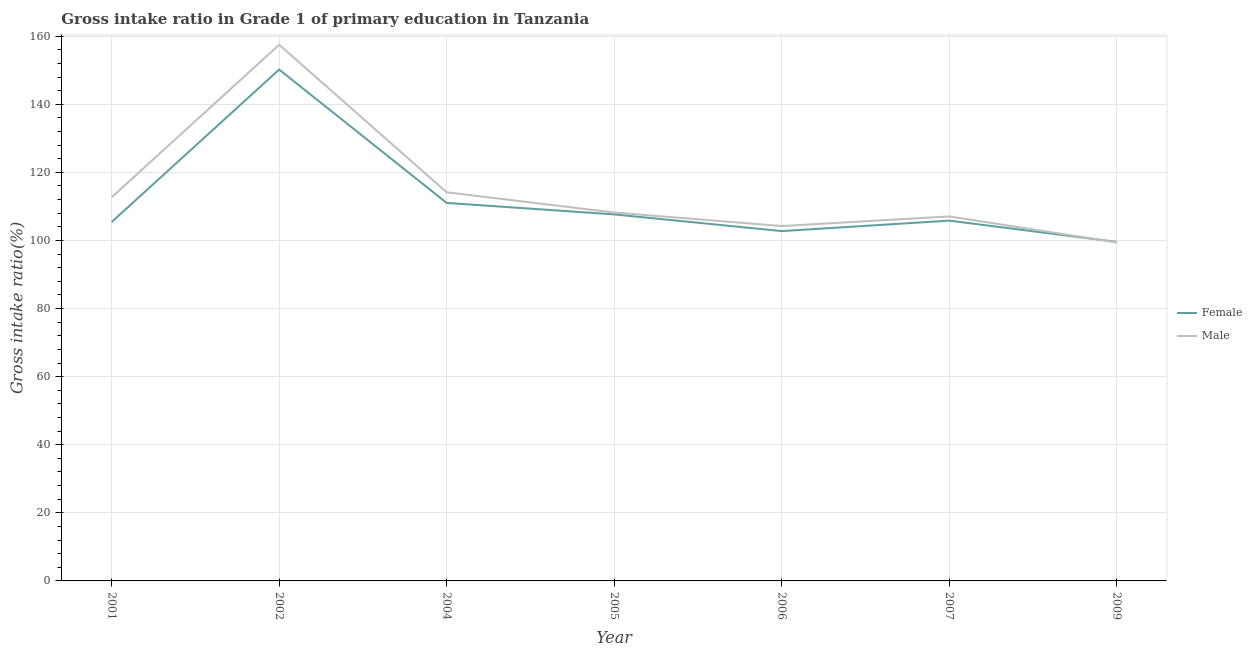Is the number of lines equal to the number of legend labels?
Your answer should be very brief. Yes. What is the gross intake ratio(male) in 2005?
Provide a succinct answer. 108.2. Across all years, what is the maximum gross intake ratio(male)?
Your response must be concise. 157.48. Across all years, what is the minimum gross intake ratio(male)?
Keep it short and to the point. 99.43. What is the total gross intake ratio(male) in the graph?
Give a very brief answer. 803.22. What is the difference between the gross intake ratio(male) in 2005 and that in 2009?
Your answer should be very brief. 8.77. What is the difference between the gross intake ratio(male) in 2001 and the gross intake ratio(female) in 2002?
Your answer should be compact. -37.51. What is the average gross intake ratio(male) per year?
Provide a succinct answer. 114.75. In the year 2002, what is the difference between the gross intake ratio(male) and gross intake ratio(female)?
Give a very brief answer. 7.28. In how many years, is the gross intake ratio(female) greater than 84 %?
Offer a terse response. 7. What is the ratio of the gross intake ratio(female) in 2001 to that in 2007?
Make the answer very short. 1. Is the gross intake ratio(female) in 2002 less than that in 2005?
Provide a succinct answer. No. Is the difference between the gross intake ratio(female) in 2002 and 2005 greater than the difference between the gross intake ratio(male) in 2002 and 2005?
Make the answer very short. No. What is the difference between the highest and the second highest gross intake ratio(female)?
Make the answer very short. 39.18. What is the difference between the highest and the lowest gross intake ratio(female)?
Provide a short and direct response. 50.63. Is the gross intake ratio(female) strictly greater than the gross intake ratio(male) over the years?
Offer a terse response. No. Is the gross intake ratio(female) strictly less than the gross intake ratio(male) over the years?
Your answer should be compact. No. What is the difference between two consecutive major ticks on the Y-axis?
Provide a succinct answer. 20. Are the values on the major ticks of Y-axis written in scientific E-notation?
Offer a terse response. No. Does the graph contain any zero values?
Provide a short and direct response. No. Where does the legend appear in the graph?
Offer a very short reply. Center right. What is the title of the graph?
Give a very brief answer. Gross intake ratio in Grade 1 of primary education in Tanzania. What is the label or title of the X-axis?
Offer a terse response. Year. What is the label or title of the Y-axis?
Keep it short and to the point. Gross intake ratio(%). What is the Gross intake ratio(%) in Female in 2001?
Offer a terse response. 105.41. What is the Gross intake ratio(%) of Male in 2001?
Provide a short and direct response. 112.69. What is the Gross intake ratio(%) in Female in 2002?
Your response must be concise. 150.2. What is the Gross intake ratio(%) in Male in 2002?
Give a very brief answer. 157.48. What is the Gross intake ratio(%) in Female in 2004?
Your answer should be very brief. 111.02. What is the Gross intake ratio(%) of Male in 2004?
Offer a terse response. 114.14. What is the Gross intake ratio(%) in Female in 2005?
Your answer should be very brief. 107.65. What is the Gross intake ratio(%) in Male in 2005?
Your answer should be compact. 108.2. What is the Gross intake ratio(%) of Female in 2006?
Your answer should be very brief. 102.75. What is the Gross intake ratio(%) in Male in 2006?
Give a very brief answer. 104.23. What is the Gross intake ratio(%) of Female in 2007?
Provide a short and direct response. 105.82. What is the Gross intake ratio(%) of Male in 2007?
Ensure brevity in your answer.  107.06. What is the Gross intake ratio(%) in Female in 2009?
Your answer should be compact. 99.57. What is the Gross intake ratio(%) of Male in 2009?
Ensure brevity in your answer.  99.43. Across all years, what is the maximum Gross intake ratio(%) in Female?
Offer a very short reply. 150.2. Across all years, what is the maximum Gross intake ratio(%) in Male?
Provide a succinct answer. 157.48. Across all years, what is the minimum Gross intake ratio(%) in Female?
Keep it short and to the point. 99.57. Across all years, what is the minimum Gross intake ratio(%) in Male?
Keep it short and to the point. 99.43. What is the total Gross intake ratio(%) of Female in the graph?
Offer a terse response. 782.42. What is the total Gross intake ratio(%) of Male in the graph?
Offer a terse response. 803.22. What is the difference between the Gross intake ratio(%) of Female in 2001 and that in 2002?
Your answer should be compact. -44.79. What is the difference between the Gross intake ratio(%) of Male in 2001 and that in 2002?
Provide a short and direct response. -44.79. What is the difference between the Gross intake ratio(%) in Female in 2001 and that in 2004?
Provide a short and direct response. -5.61. What is the difference between the Gross intake ratio(%) of Male in 2001 and that in 2004?
Ensure brevity in your answer.  -1.45. What is the difference between the Gross intake ratio(%) of Female in 2001 and that in 2005?
Provide a short and direct response. -2.24. What is the difference between the Gross intake ratio(%) of Male in 2001 and that in 2005?
Give a very brief answer. 4.49. What is the difference between the Gross intake ratio(%) in Female in 2001 and that in 2006?
Offer a terse response. 2.66. What is the difference between the Gross intake ratio(%) of Male in 2001 and that in 2006?
Your answer should be compact. 8.45. What is the difference between the Gross intake ratio(%) of Female in 2001 and that in 2007?
Your response must be concise. -0.41. What is the difference between the Gross intake ratio(%) of Male in 2001 and that in 2007?
Your response must be concise. 5.63. What is the difference between the Gross intake ratio(%) of Female in 2001 and that in 2009?
Give a very brief answer. 5.84. What is the difference between the Gross intake ratio(%) of Male in 2001 and that in 2009?
Ensure brevity in your answer.  13.26. What is the difference between the Gross intake ratio(%) in Female in 2002 and that in 2004?
Make the answer very short. 39.18. What is the difference between the Gross intake ratio(%) in Male in 2002 and that in 2004?
Offer a very short reply. 43.34. What is the difference between the Gross intake ratio(%) in Female in 2002 and that in 2005?
Your answer should be very brief. 42.55. What is the difference between the Gross intake ratio(%) in Male in 2002 and that in 2005?
Provide a succinct answer. 49.28. What is the difference between the Gross intake ratio(%) in Female in 2002 and that in 2006?
Offer a terse response. 47.45. What is the difference between the Gross intake ratio(%) in Male in 2002 and that in 2006?
Your answer should be very brief. 53.24. What is the difference between the Gross intake ratio(%) of Female in 2002 and that in 2007?
Give a very brief answer. 44.38. What is the difference between the Gross intake ratio(%) of Male in 2002 and that in 2007?
Provide a succinct answer. 50.42. What is the difference between the Gross intake ratio(%) in Female in 2002 and that in 2009?
Offer a very short reply. 50.63. What is the difference between the Gross intake ratio(%) in Male in 2002 and that in 2009?
Make the answer very short. 58.05. What is the difference between the Gross intake ratio(%) in Female in 2004 and that in 2005?
Give a very brief answer. 3.37. What is the difference between the Gross intake ratio(%) in Male in 2004 and that in 2005?
Your response must be concise. 5.94. What is the difference between the Gross intake ratio(%) of Female in 2004 and that in 2006?
Make the answer very short. 8.27. What is the difference between the Gross intake ratio(%) in Male in 2004 and that in 2006?
Make the answer very short. 9.91. What is the difference between the Gross intake ratio(%) of Female in 2004 and that in 2007?
Your answer should be compact. 5.2. What is the difference between the Gross intake ratio(%) in Male in 2004 and that in 2007?
Provide a short and direct response. 7.08. What is the difference between the Gross intake ratio(%) in Female in 2004 and that in 2009?
Keep it short and to the point. 11.45. What is the difference between the Gross intake ratio(%) of Male in 2004 and that in 2009?
Ensure brevity in your answer.  14.71. What is the difference between the Gross intake ratio(%) in Female in 2005 and that in 2006?
Offer a very short reply. 4.91. What is the difference between the Gross intake ratio(%) of Male in 2005 and that in 2006?
Your response must be concise. 3.96. What is the difference between the Gross intake ratio(%) in Female in 2005 and that in 2007?
Your answer should be very brief. 1.83. What is the difference between the Gross intake ratio(%) in Male in 2005 and that in 2007?
Offer a terse response. 1.14. What is the difference between the Gross intake ratio(%) in Female in 2005 and that in 2009?
Your answer should be compact. 8.08. What is the difference between the Gross intake ratio(%) in Male in 2005 and that in 2009?
Make the answer very short. 8.77. What is the difference between the Gross intake ratio(%) of Female in 2006 and that in 2007?
Offer a terse response. -3.07. What is the difference between the Gross intake ratio(%) in Male in 2006 and that in 2007?
Keep it short and to the point. -2.82. What is the difference between the Gross intake ratio(%) of Female in 2006 and that in 2009?
Offer a very short reply. 3.18. What is the difference between the Gross intake ratio(%) of Male in 2006 and that in 2009?
Offer a terse response. 4.8. What is the difference between the Gross intake ratio(%) of Female in 2007 and that in 2009?
Your response must be concise. 6.25. What is the difference between the Gross intake ratio(%) in Male in 2007 and that in 2009?
Your response must be concise. 7.63. What is the difference between the Gross intake ratio(%) of Female in 2001 and the Gross intake ratio(%) of Male in 2002?
Ensure brevity in your answer.  -52.07. What is the difference between the Gross intake ratio(%) of Female in 2001 and the Gross intake ratio(%) of Male in 2004?
Ensure brevity in your answer.  -8.73. What is the difference between the Gross intake ratio(%) in Female in 2001 and the Gross intake ratio(%) in Male in 2005?
Your answer should be compact. -2.79. What is the difference between the Gross intake ratio(%) of Female in 2001 and the Gross intake ratio(%) of Male in 2006?
Your response must be concise. 1.18. What is the difference between the Gross intake ratio(%) of Female in 2001 and the Gross intake ratio(%) of Male in 2007?
Your response must be concise. -1.65. What is the difference between the Gross intake ratio(%) of Female in 2001 and the Gross intake ratio(%) of Male in 2009?
Offer a very short reply. 5.98. What is the difference between the Gross intake ratio(%) of Female in 2002 and the Gross intake ratio(%) of Male in 2004?
Give a very brief answer. 36.06. What is the difference between the Gross intake ratio(%) in Female in 2002 and the Gross intake ratio(%) in Male in 2005?
Provide a succinct answer. 42. What is the difference between the Gross intake ratio(%) of Female in 2002 and the Gross intake ratio(%) of Male in 2006?
Offer a very short reply. 45.97. What is the difference between the Gross intake ratio(%) in Female in 2002 and the Gross intake ratio(%) in Male in 2007?
Make the answer very short. 43.14. What is the difference between the Gross intake ratio(%) in Female in 2002 and the Gross intake ratio(%) in Male in 2009?
Offer a terse response. 50.77. What is the difference between the Gross intake ratio(%) of Female in 2004 and the Gross intake ratio(%) of Male in 2005?
Give a very brief answer. 2.82. What is the difference between the Gross intake ratio(%) in Female in 2004 and the Gross intake ratio(%) in Male in 2006?
Offer a very short reply. 6.79. What is the difference between the Gross intake ratio(%) in Female in 2004 and the Gross intake ratio(%) in Male in 2007?
Provide a short and direct response. 3.96. What is the difference between the Gross intake ratio(%) of Female in 2004 and the Gross intake ratio(%) of Male in 2009?
Your response must be concise. 11.59. What is the difference between the Gross intake ratio(%) of Female in 2005 and the Gross intake ratio(%) of Male in 2006?
Your answer should be very brief. 3.42. What is the difference between the Gross intake ratio(%) of Female in 2005 and the Gross intake ratio(%) of Male in 2007?
Your answer should be compact. 0.6. What is the difference between the Gross intake ratio(%) of Female in 2005 and the Gross intake ratio(%) of Male in 2009?
Your answer should be compact. 8.22. What is the difference between the Gross intake ratio(%) of Female in 2006 and the Gross intake ratio(%) of Male in 2007?
Your answer should be compact. -4.31. What is the difference between the Gross intake ratio(%) of Female in 2006 and the Gross intake ratio(%) of Male in 2009?
Give a very brief answer. 3.32. What is the difference between the Gross intake ratio(%) in Female in 2007 and the Gross intake ratio(%) in Male in 2009?
Your answer should be compact. 6.39. What is the average Gross intake ratio(%) of Female per year?
Give a very brief answer. 111.77. What is the average Gross intake ratio(%) in Male per year?
Keep it short and to the point. 114.75. In the year 2001, what is the difference between the Gross intake ratio(%) in Female and Gross intake ratio(%) in Male?
Your response must be concise. -7.28. In the year 2002, what is the difference between the Gross intake ratio(%) in Female and Gross intake ratio(%) in Male?
Offer a very short reply. -7.28. In the year 2004, what is the difference between the Gross intake ratio(%) of Female and Gross intake ratio(%) of Male?
Your response must be concise. -3.12. In the year 2005, what is the difference between the Gross intake ratio(%) of Female and Gross intake ratio(%) of Male?
Provide a short and direct response. -0.55. In the year 2006, what is the difference between the Gross intake ratio(%) of Female and Gross intake ratio(%) of Male?
Provide a short and direct response. -1.49. In the year 2007, what is the difference between the Gross intake ratio(%) in Female and Gross intake ratio(%) in Male?
Provide a succinct answer. -1.24. In the year 2009, what is the difference between the Gross intake ratio(%) in Female and Gross intake ratio(%) in Male?
Ensure brevity in your answer.  0.14. What is the ratio of the Gross intake ratio(%) in Female in 2001 to that in 2002?
Keep it short and to the point. 0.7. What is the ratio of the Gross intake ratio(%) of Male in 2001 to that in 2002?
Offer a very short reply. 0.72. What is the ratio of the Gross intake ratio(%) of Female in 2001 to that in 2004?
Provide a short and direct response. 0.95. What is the ratio of the Gross intake ratio(%) in Male in 2001 to that in 2004?
Offer a very short reply. 0.99. What is the ratio of the Gross intake ratio(%) in Female in 2001 to that in 2005?
Your answer should be very brief. 0.98. What is the ratio of the Gross intake ratio(%) of Male in 2001 to that in 2005?
Your response must be concise. 1.04. What is the ratio of the Gross intake ratio(%) of Female in 2001 to that in 2006?
Offer a terse response. 1.03. What is the ratio of the Gross intake ratio(%) in Male in 2001 to that in 2006?
Keep it short and to the point. 1.08. What is the ratio of the Gross intake ratio(%) in Female in 2001 to that in 2007?
Make the answer very short. 1. What is the ratio of the Gross intake ratio(%) of Male in 2001 to that in 2007?
Give a very brief answer. 1.05. What is the ratio of the Gross intake ratio(%) in Female in 2001 to that in 2009?
Give a very brief answer. 1.06. What is the ratio of the Gross intake ratio(%) of Male in 2001 to that in 2009?
Provide a succinct answer. 1.13. What is the ratio of the Gross intake ratio(%) in Female in 2002 to that in 2004?
Give a very brief answer. 1.35. What is the ratio of the Gross intake ratio(%) in Male in 2002 to that in 2004?
Give a very brief answer. 1.38. What is the ratio of the Gross intake ratio(%) in Female in 2002 to that in 2005?
Offer a very short reply. 1.4. What is the ratio of the Gross intake ratio(%) of Male in 2002 to that in 2005?
Make the answer very short. 1.46. What is the ratio of the Gross intake ratio(%) in Female in 2002 to that in 2006?
Offer a very short reply. 1.46. What is the ratio of the Gross intake ratio(%) in Male in 2002 to that in 2006?
Keep it short and to the point. 1.51. What is the ratio of the Gross intake ratio(%) of Female in 2002 to that in 2007?
Ensure brevity in your answer.  1.42. What is the ratio of the Gross intake ratio(%) of Male in 2002 to that in 2007?
Ensure brevity in your answer.  1.47. What is the ratio of the Gross intake ratio(%) of Female in 2002 to that in 2009?
Give a very brief answer. 1.51. What is the ratio of the Gross intake ratio(%) of Male in 2002 to that in 2009?
Your answer should be very brief. 1.58. What is the ratio of the Gross intake ratio(%) of Female in 2004 to that in 2005?
Make the answer very short. 1.03. What is the ratio of the Gross intake ratio(%) in Male in 2004 to that in 2005?
Offer a terse response. 1.05. What is the ratio of the Gross intake ratio(%) in Female in 2004 to that in 2006?
Give a very brief answer. 1.08. What is the ratio of the Gross intake ratio(%) of Male in 2004 to that in 2006?
Offer a terse response. 1.1. What is the ratio of the Gross intake ratio(%) in Female in 2004 to that in 2007?
Offer a terse response. 1.05. What is the ratio of the Gross intake ratio(%) of Male in 2004 to that in 2007?
Your response must be concise. 1.07. What is the ratio of the Gross intake ratio(%) of Female in 2004 to that in 2009?
Provide a short and direct response. 1.11. What is the ratio of the Gross intake ratio(%) in Male in 2004 to that in 2009?
Your response must be concise. 1.15. What is the ratio of the Gross intake ratio(%) of Female in 2005 to that in 2006?
Ensure brevity in your answer.  1.05. What is the ratio of the Gross intake ratio(%) of Male in 2005 to that in 2006?
Your response must be concise. 1.04. What is the ratio of the Gross intake ratio(%) in Female in 2005 to that in 2007?
Provide a succinct answer. 1.02. What is the ratio of the Gross intake ratio(%) in Male in 2005 to that in 2007?
Offer a very short reply. 1.01. What is the ratio of the Gross intake ratio(%) of Female in 2005 to that in 2009?
Your answer should be compact. 1.08. What is the ratio of the Gross intake ratio(%) in Male in 2005 to that in 2009?
Give a very brief answer. 1.09. What is the ratio of the Gross intake ratio(%) of Female in 2006 to that in 2007?
Make the answer very short. 0.97. What is the ratio of the Gross intake ratio(%) in Male in 2006 to that in 2007?
Ensure brevity in your answer.  0.97. What is the ratio of the Gross intake ratio(%) in Female in 2006 to that in 2009?
Provide a short and direct response. 1.03. What is the ratio of the Gross intake ratio(%) in Male in 2006 to that in 2009?
Provide a succinct answer. 1.05. What is the ratio of the Gross intake ratio(%) in Female in 2007 to that in 2009?
Provide a short and direct response. 1.06. What is the ratio of the Gross intake ratio(%) in Male in 2007 to that in 2009?
Offer a very short reply. 1.08. What is the difference between the highest and the second highest Gross intake ratio(%) in Female?
Your response must be concise. 39.18. What is the difference between the highest and the second highest Gross intake ratio(%) in Male?
Ensure brevity in your answer.  43.34. What is the difference between the highest and the lowest Gross intake ratio(%) of Female?
Provide a succinct answer. 50.63. What is the difference between the highest and the lowest Gross intake ratio(%) in Male?
Give a very brief answer. 58.05. 